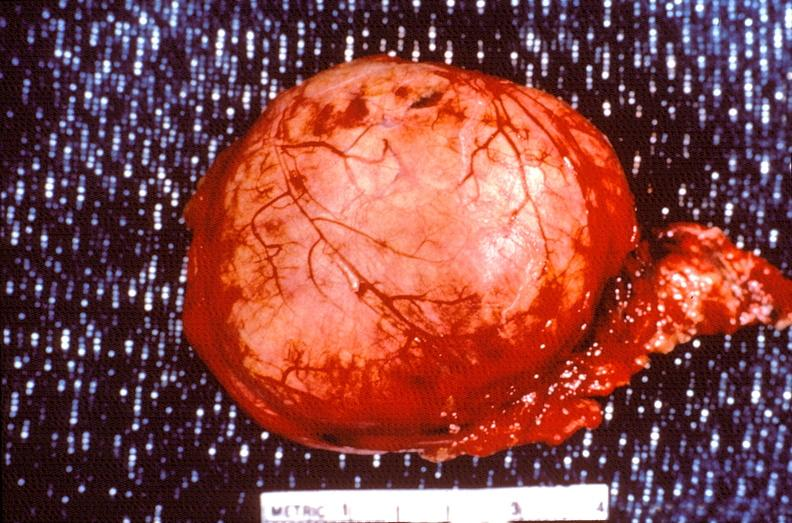where does this belong to?
Answer the question using a single word or phrase. Endocrine system 